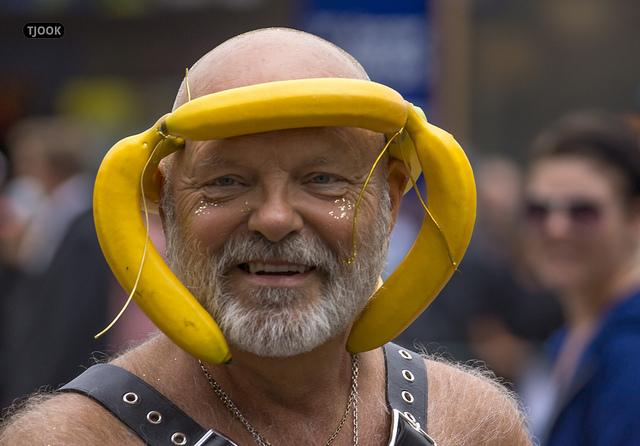If the man eats what is around his head what vitamin will he get?

Choices:
A) vitamin c
B) vitamin w
C) vitamin d
D) vitamin r vitamin c 